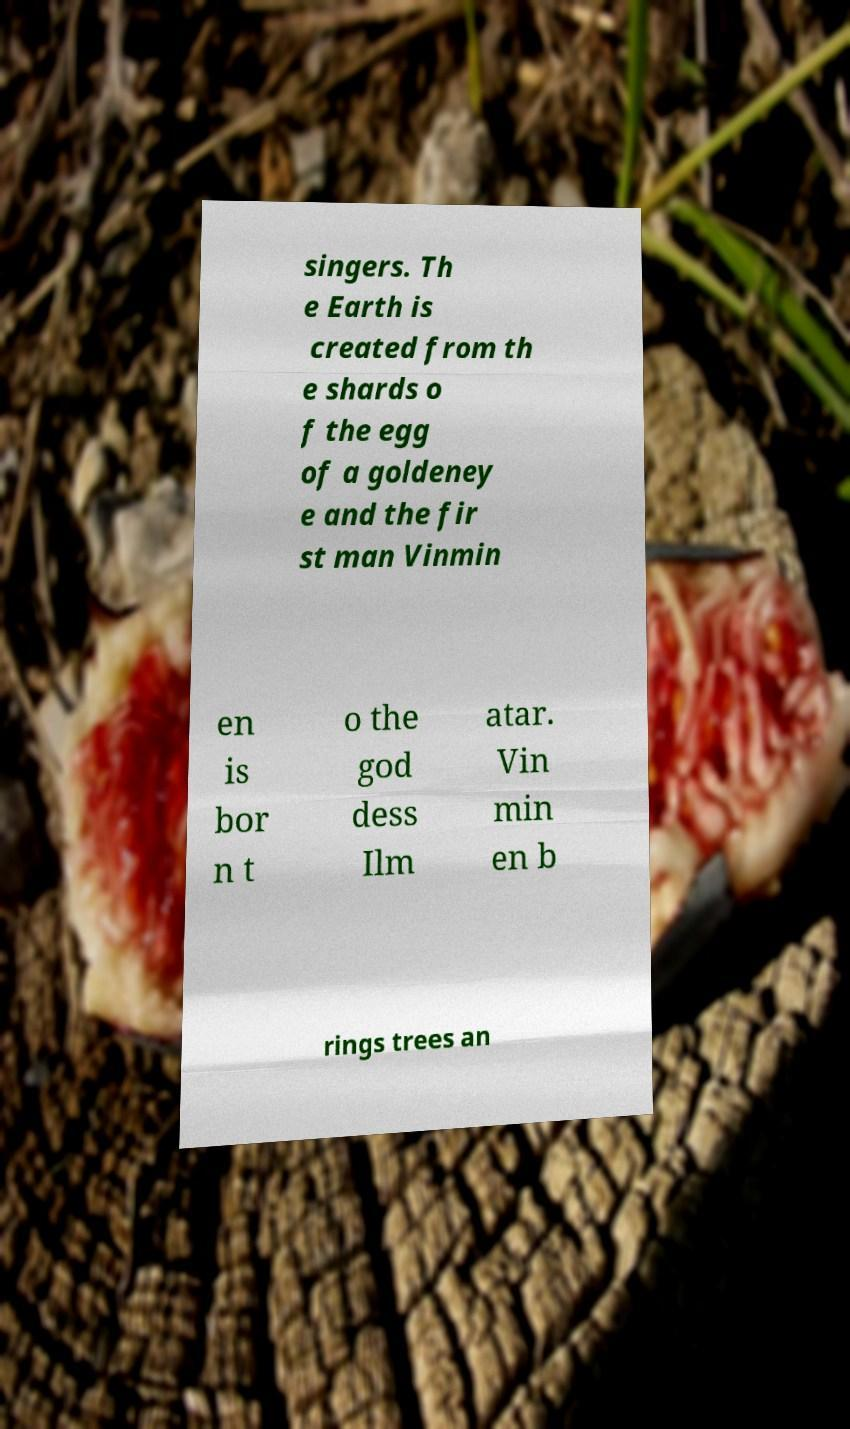What messages or text are displayed in this image? I need them in a readable, typed format. singers. Th e Earth is created from th e shards o f the egg of a goldeney e and the fir st man Vinmin en is bor n t o the god dess Ilm atar. Vin min en b rings trees an 